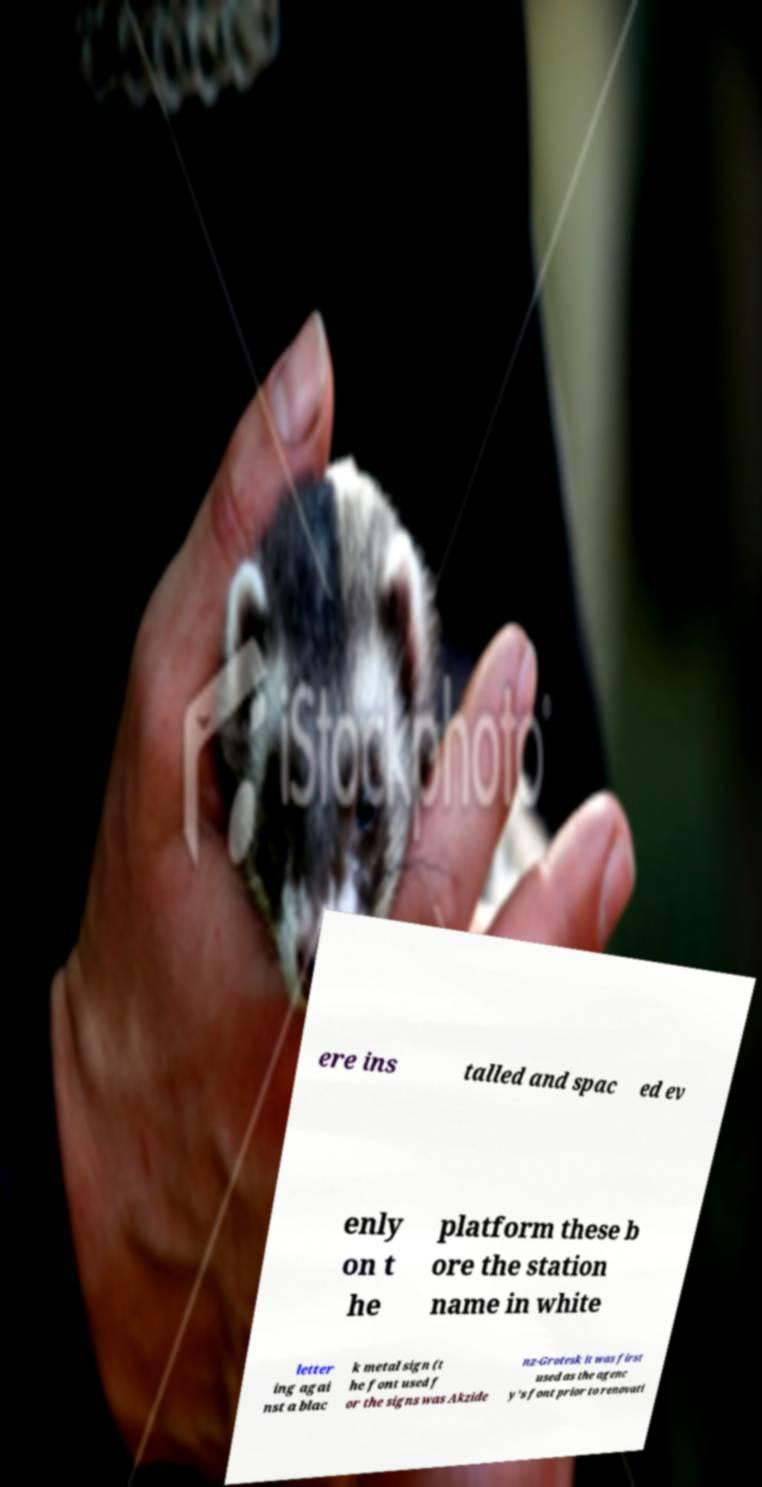What messages or text are displayed in this image? I need them in a readable, typed format. ere ins talled and spac ed ev enly on t he platform these b ore the station name in white letter ing agai nst a blac k metal sign (t he font used f or the signs was Akzide nz-Grotesk it was first used as the agenc y's font prior to renovati 